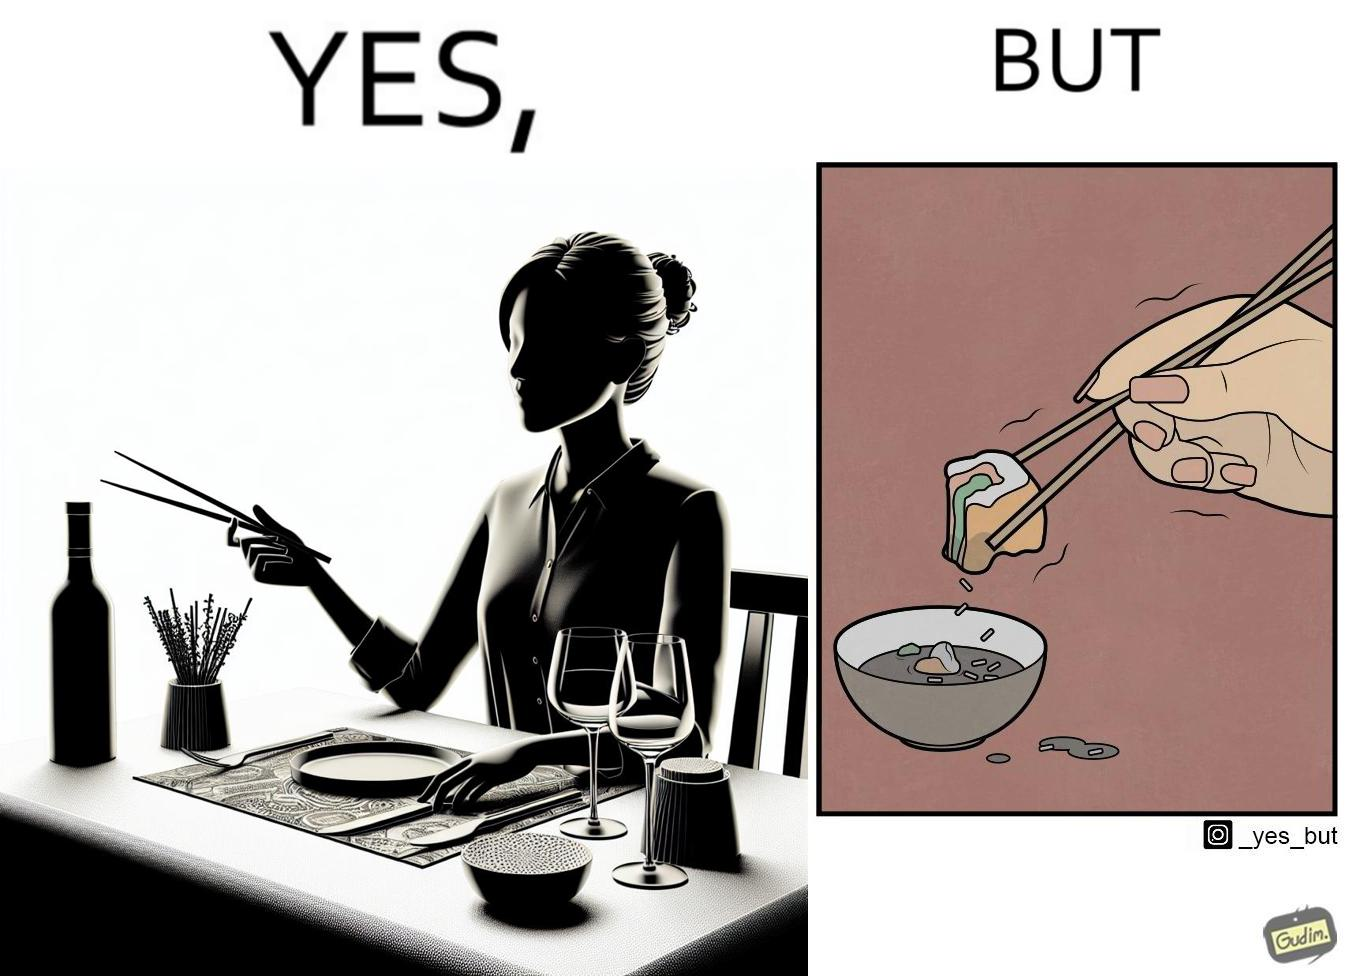Describe what you see in this image. The image is satirical because even thought the woman is not able to eat food with chopstick properly, she chooses it over fork and knife to look sophisticaed. 